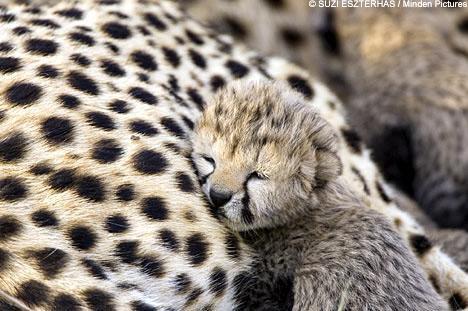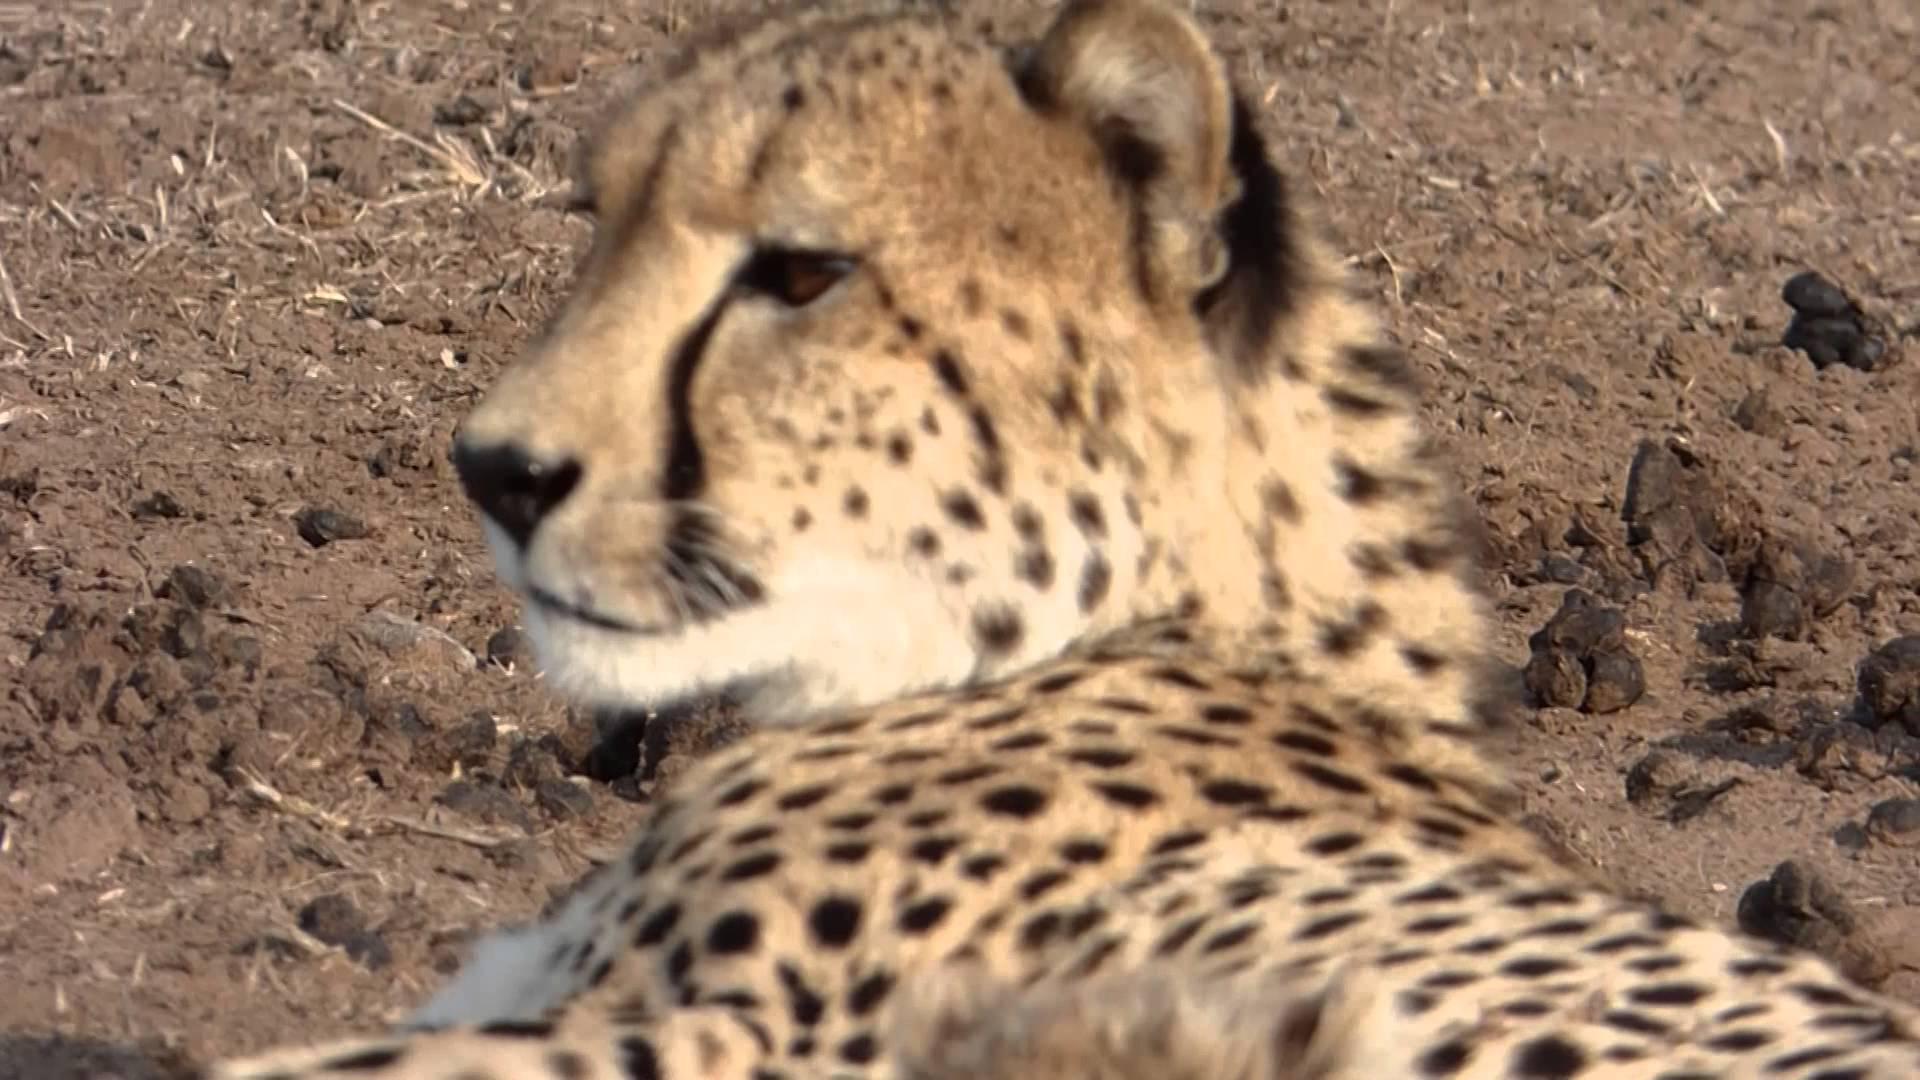The first image is the image on the left, the second image is the image on the right. Considering the images on both sides, is "In the image to the right, a cheetah kitten is laying down, looking forwards." valid? Answer yes or no. No. The first image is the image on the left, the second image is the image on the right. Considering the images on both sides, is "A baby leopard is laying next to its mom." valid? Answer yes or no. Yes. 